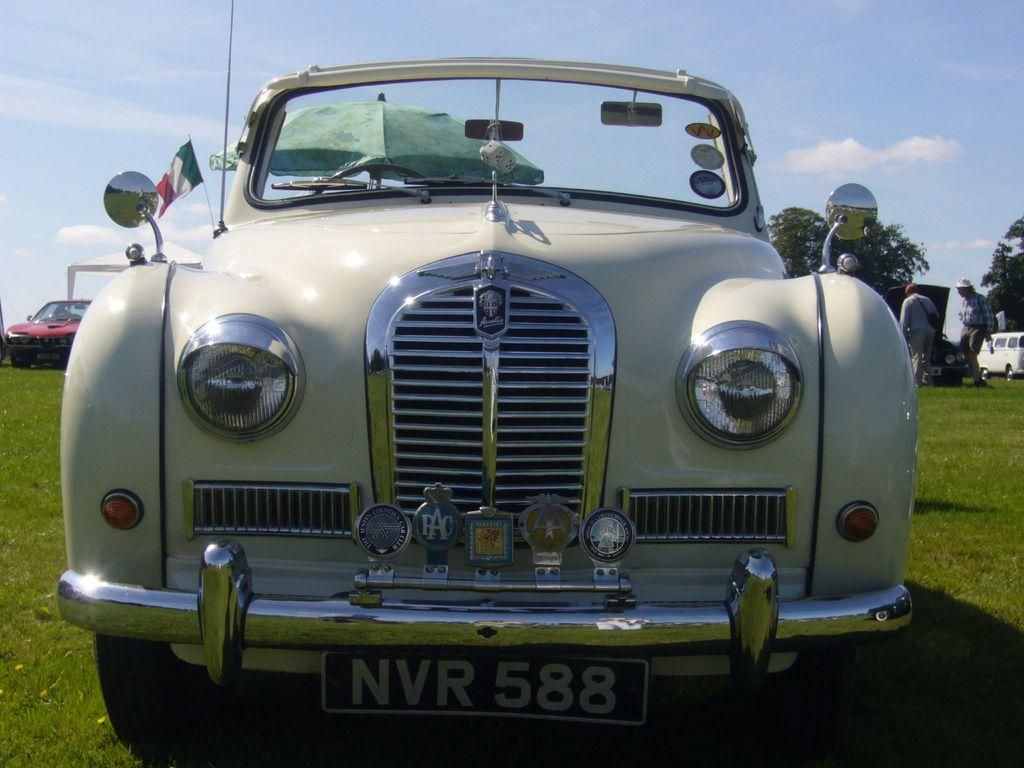What type of vehicles can be seen in the image? There are cars in the image. What natural elements are present in the image? There are trees and grass on the ground in the image. Can you describe the people in the image? There are people standing in the image. What additional objects can be seen in the image? There is an umbrella and a flag in the image. How would you describe the sky in the image? The sky is blue and cloudy in the image. How many sisters are sitting on the base in the image? There are no sisters or base present in the image. What position does the flag hold in the image? The flag is simply visible in the image, and its position is not described in the provided facts. 